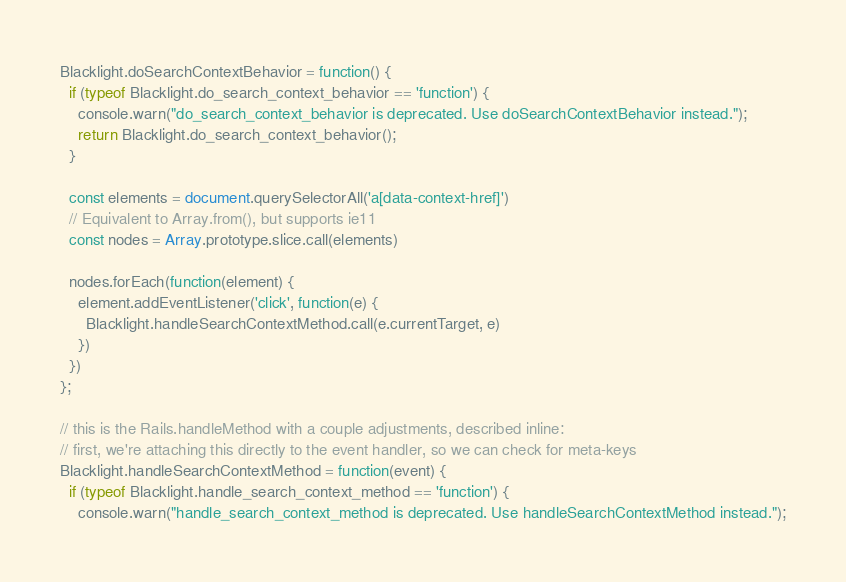Convert code to text. <code><loc_0><loc_0><loc_500><loc_500><_JavaScript_>Blacklight.doSearchContextBehavior = function() {
  if (typeof Blacklight.do_search_context_behavior == 'function') {
    console.warn("do_search_context_behavior is deprecated. Use doSearchContextBehavior instead.");
    return Blacklight.do_search_context_behavior();
  }

  const elements = document.querySelectorAll('a[data-context-href]')
  // Equivalent to Array.from(), but supports ie11
  const nodes = Array.prototype.slice.call(elements)

  nodes.forEach(function(element) {
    element.addEventListener('click', function(e) {
      Blacklight.handleSearchContextMethod.call(e.currentTarget, e)
    })
  })
};

// this is the Rails.handleMethod with a couple adjustments, described inline:
// first, we're attaching this directly to the event handler, so we can check for meta-keys
Blacklight.handleSearchContextMethod = function(event) {
  if (typeof Blacklight.handle_search_context_method == 'function') {
    console.warn("handle_search_context_method is deprecated. Use handleSearchContextMethod instead.");</code> 